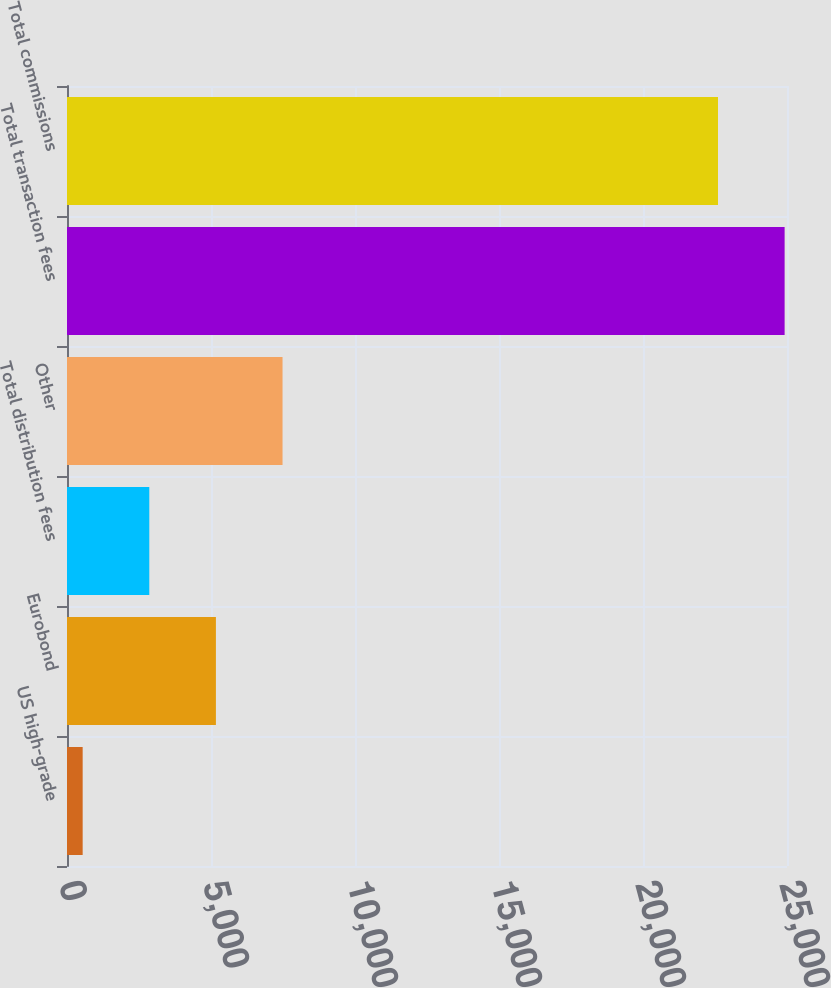<chart> <loc_0><loc_0><loc_500><loc_500><bar_chart><fcel>US high-grade<fcel>Eurobond<fcel>Total distribution fees<fcel>Other<fcel>Total transaction fees<fcel>Total commissions<nl><fcel>544<fcel>5170.6<fcel>2857.3<fcel>7483.9<fcel>24917.3<fcel>22604<nl></chart> 